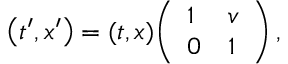Convert formula to latex. <formula><loc_0><loc_0><loc_500><loc_500>\left ( t ^ { \prime } , x ^ { \prime } \right ) = ( t , x ) { \left ( \begin{array} { l l } { 1 } & { v } \\ { 0 } & { 1 } \end{array} \right ) } \, ,</formula> 